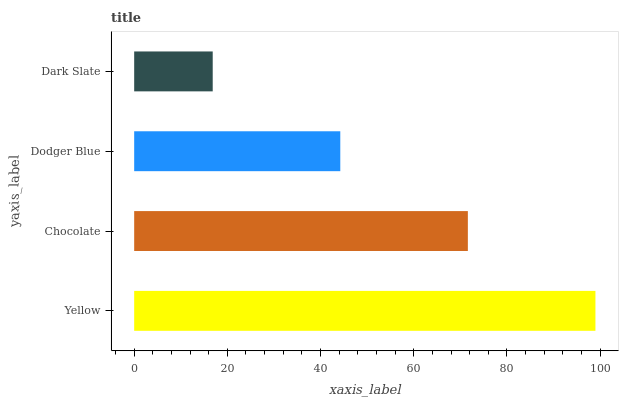Is Dark Slate the minimum?
Answer yes or no. Yes. Is Yellow the maximum?
Answer yes or no. Yes. Is Chocolate the minimum?
Answer yes or no. No. Is Chocolate the maximum?
Answer yes or no. No. Is Yellow greater than Chocolate?
Answer yes or no. Yes. Is Chocolate less than Yellow?
Answer yes or no. Yes. Is Chocolate greater than Yellow?
Answer yes or no. No. Is Yellow less than Chocolate?
Answer yes or no. No. Is Chocolate the high median?
Answer yes or no. Yes. Is Dodger Blue the low median?
Answer yes or no. Yes. Is Yellow the high median?
Answer yes or no. No. Is Dark Slate the low median?
Answer yes or no. No. 